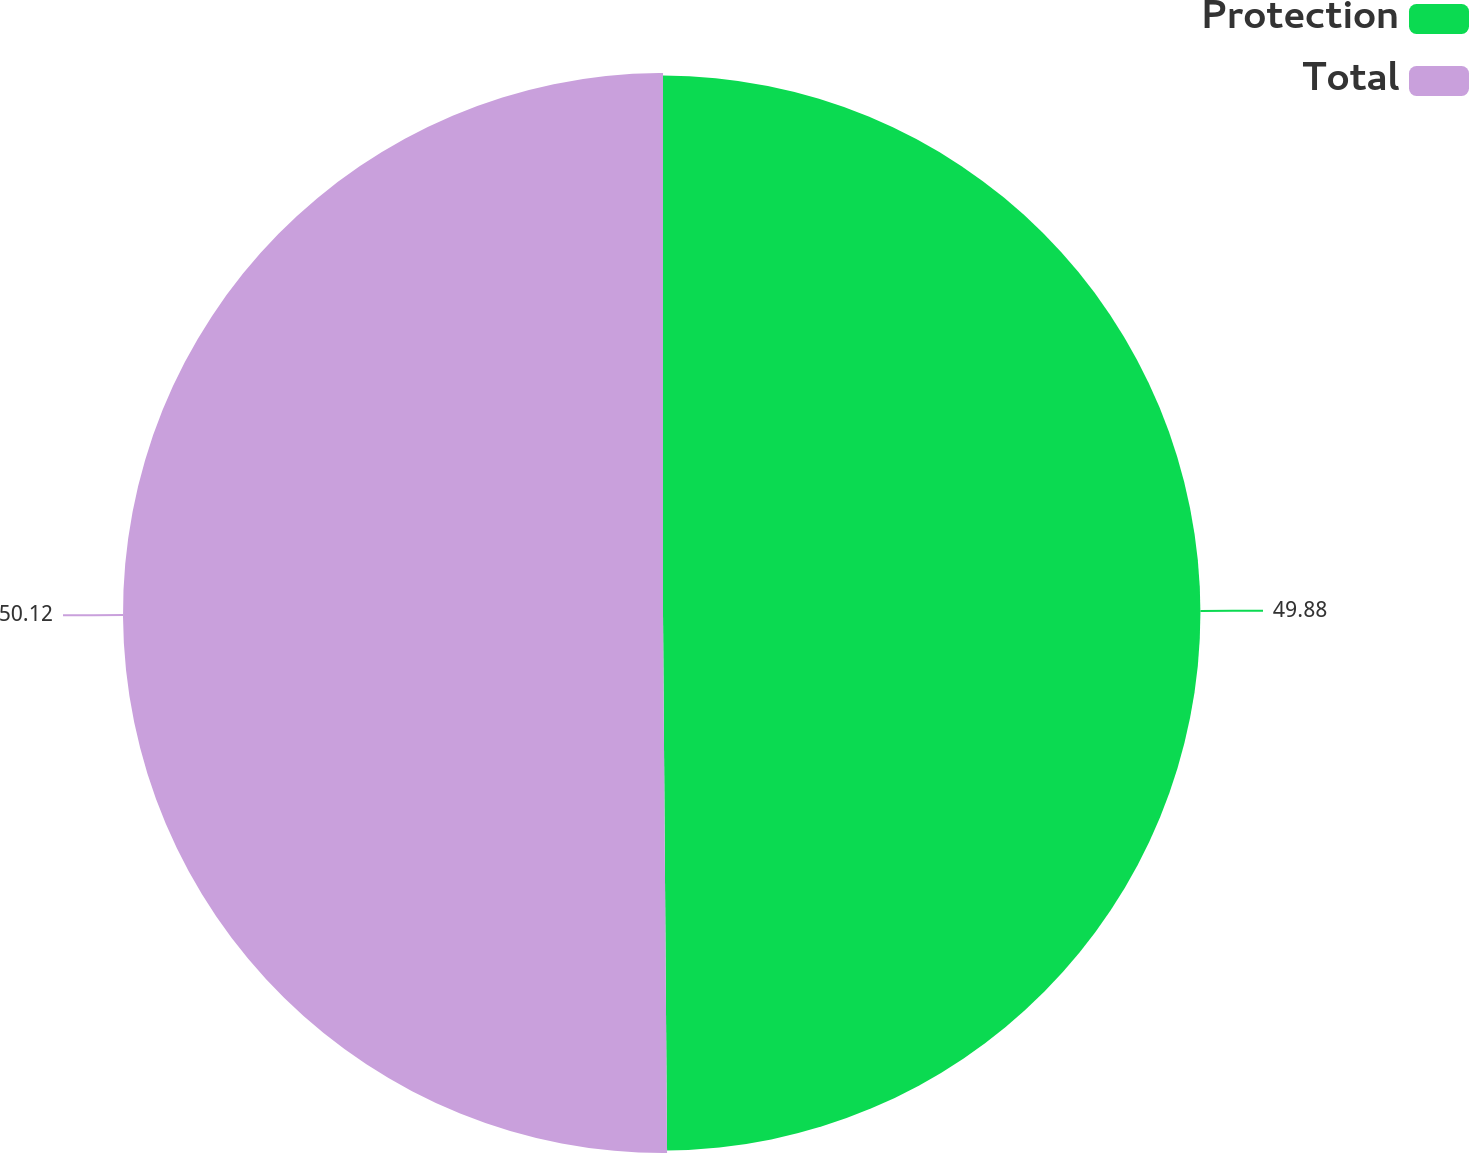<chart> <loc_0><loc_0><loc_500><loc_500><pie_chart><fcel>Protection<fcel>Total<nl><fcel>49.88%<fcel>50.12%<nl></chart> 